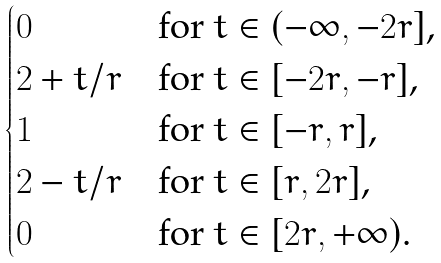<formula> <loc_0><loc_0><loc_500><loc_500>\begin{cases} 0 & \text {for $t\in(-\infty,-2r]$,} \\ 2 + t / r & \text {for $t\in[-2r,-r]$,} \\ 1 & \text {for $t\in[-r,r]$,} \\ 2 - t / r & \text {for $t\in[r,2r]$,} \\ 0 & \text {for $t\in[2r,+\infty)$.} \end{cases}</formula> 